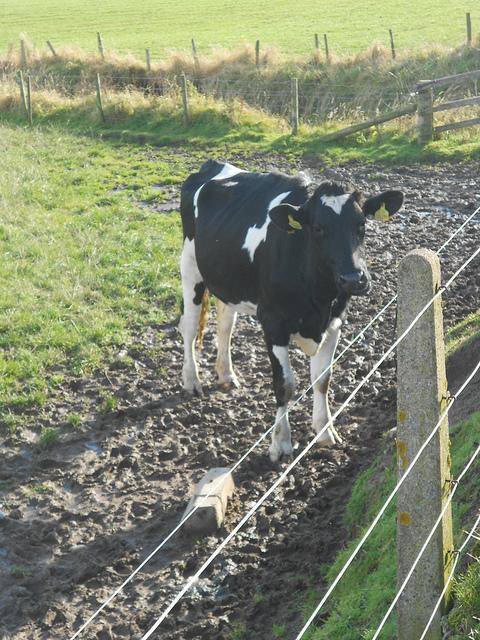How many cows are there?
Give a very brief answer. 1. 